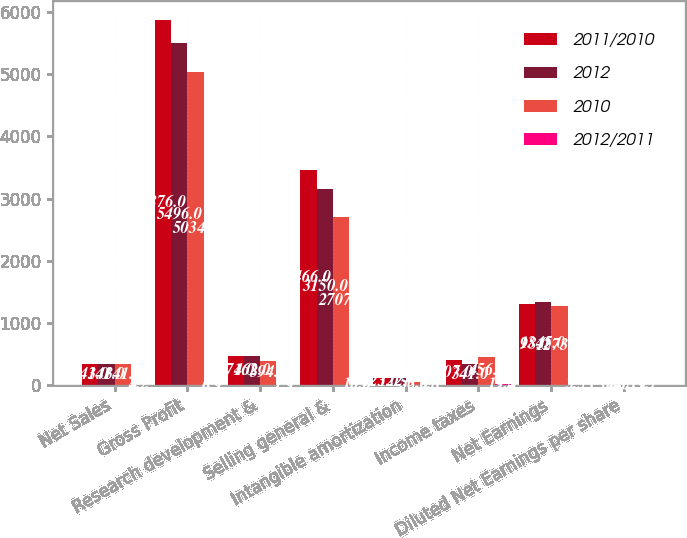<chart> <loc_0><loc_0><loc_500><loc_500><stacked_bar_chart><ecel><fcel>Net Sales<fcel>Gross Profit<fcel>Research development &<fcel>Selling general &<fcel>Intangible amortization<fcel>Income taxes<fcel>Net Earnings<fcel>Diluted Net Earnings per share<nl><fcel>2011/2010<fcel>341<fcel>5876<fcel>471<fcel>3466<fcel>123<fcel>407<fcel>1298<fcel>3.39<nl><fcel>2012<fcel>341<fcel>5496<fcel>462<fcel>3150<fcel>122<fcel>341<fcel>1345<fcel>3.45<nl><fcel>2010<fcel>341<fcel>5034<fcel>394<fcel>2707<fcel>58<fcel>456<fcel>1273<fcel>3.19<nl><fcel>2012/2011<fcel>4.2<fcel>6.9<fcel>1.9<fcel>10<fcel>0.8<fcel>19.4<fcel>3.5<fcel>1.7<nl></chart> 